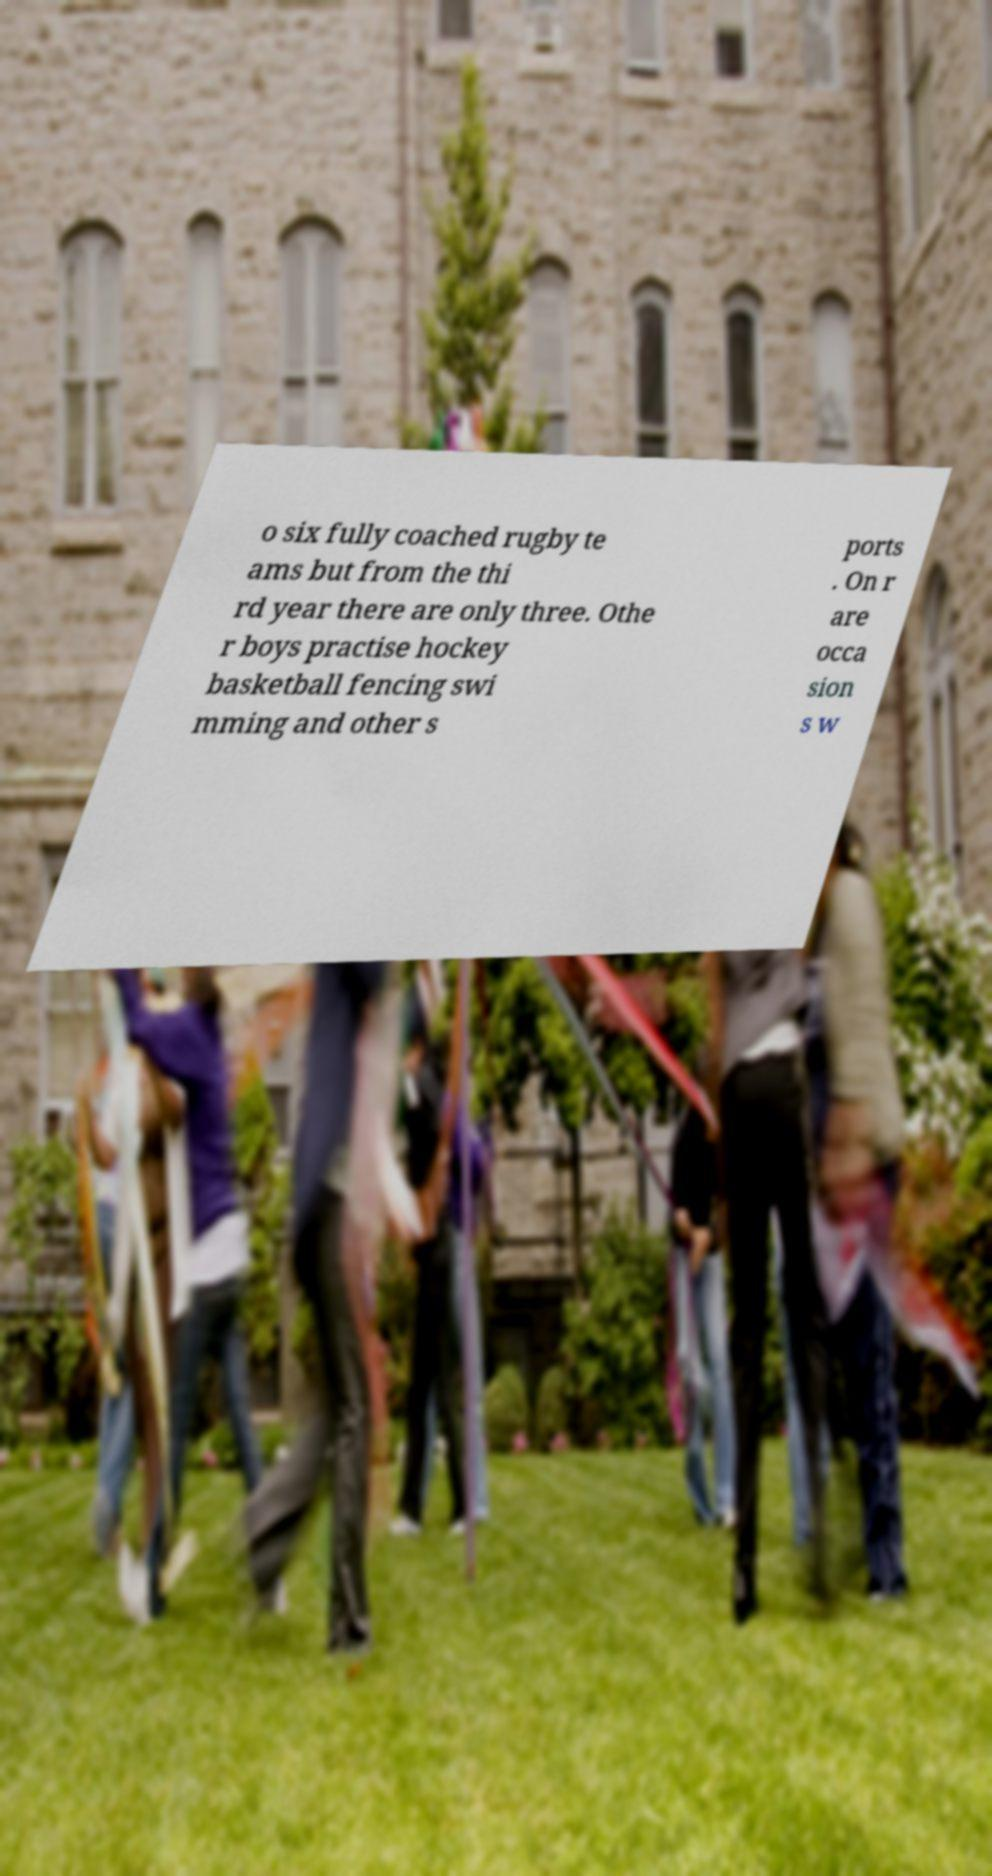What messages or text are displayed in this image? I need them in a readable, typed format. o six fully coached rugby te ams but from the thi rd year there are only three. Othe r boys practise hockey basketball fencing swi mming and other s ports . On r are occa sion s w 